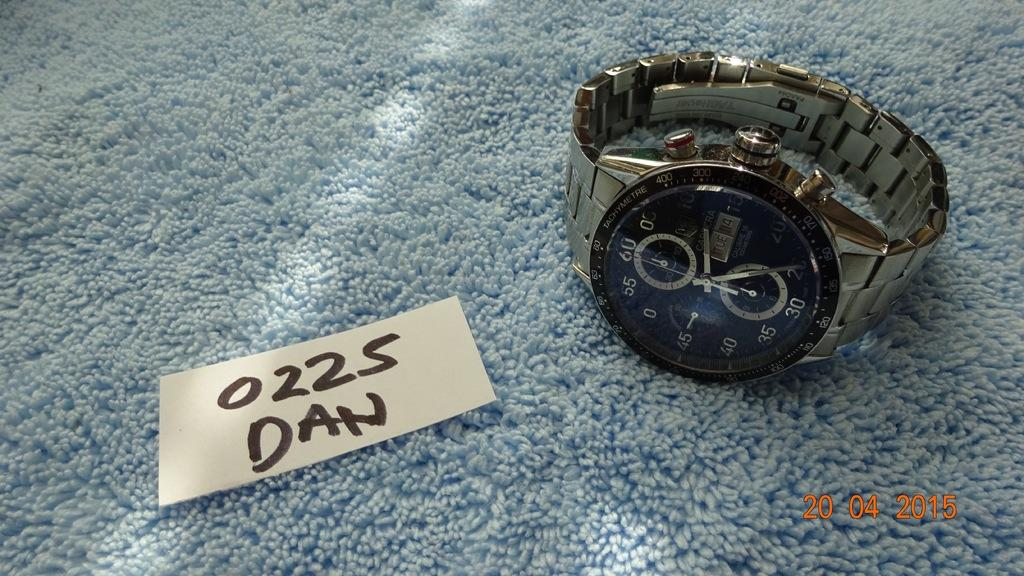<image>
Offer a succinct explanation of the picture presented. Golden watch in front of a piece of paper which says DAN. 